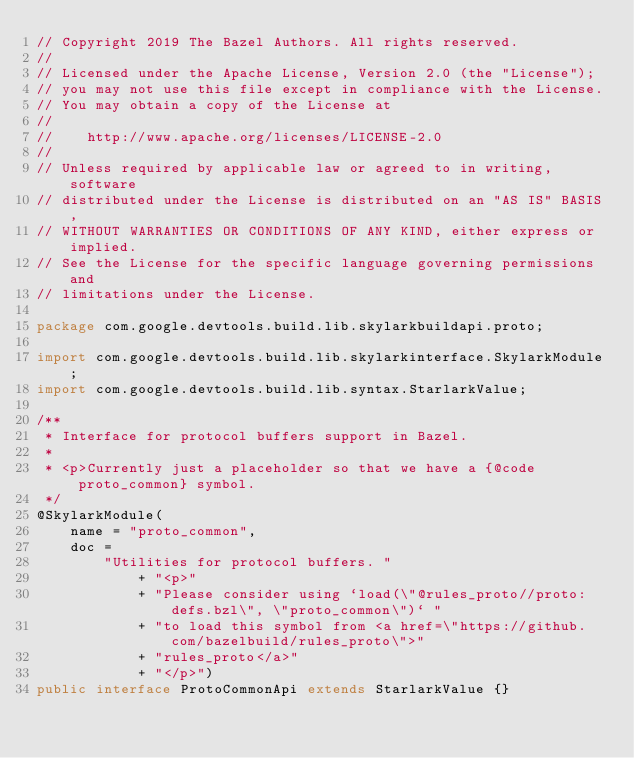<code> <loc_0><loc_0><loc_500><loc_500><_Java_>// Copyright 2019 The Bazel Authors. All rights reserved.
//
// Licensed under the Apache License, Version 2.0 (the "License");
// you may not use this file except in compliance with the License.
// You may obtain a copy of the License at
//
//    http://www.apache.org/licenses/LICENSE-2.0
//
// Unless required by applicable law or agreed to in writing, software
// distributed under the License is distributed on an "AS IS" BASIS,
// WITHOUT WARRANTIES OR CONDITIONS OF ANY KIND, either express or implied.
// See the License for the specific language governing permissions and
// limitations under the License.

package com.google.devtools.build.lib.skylarkbuildapi.proto;

import com.google.devtools.build.lib.skylarkinterface.SkylarkModule;
import com.google.devtools.build.lib.syntax.StarlarkValue;

/**
 * Interface for protocol buffers support in Bazel.
 *
 * <p>Currently just a placeholder so that we have a {@code proto_common} symbol.
 */
@SkylarkModule(
    name = "proto_common",
    doc =
        "Utilities for protocol buffers. "
            + "<p>"
            + "Please consider using `load(\"@rules_proto//proto:defs.bzl\", \"proto_common\")` "
            + "to load this symbol from <a href=\"https://github.com/bazelbuild/rules_proto\">"
            + "rules_proto</a>"
            + "</p>")
public interface ProtoCommonApi extends StarlarkValue {}
</code> 